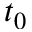Convert formula to latex. <formula><loc_0><loc_0><loc_500><loc_500>t _ { 0 }</formula> 